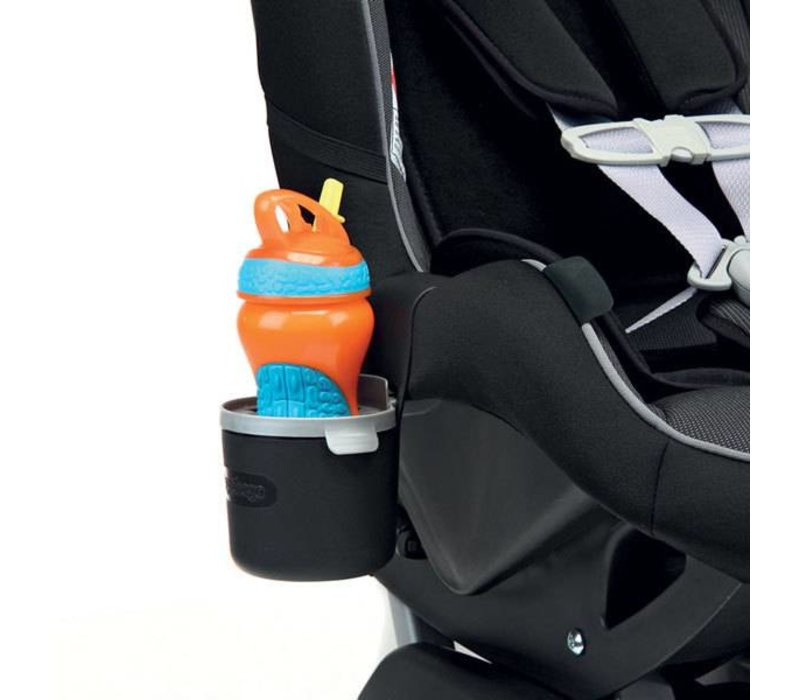Can the material of the car seat and the sippy cup be linked to environmentally friendly practices? While the image does not specify materials, manufacturers often use recyclable plastics and eco-friendly fabrics in modern car seats and sippy cups to appeal to environmentally conscious consumers. These materials are selected not only for durability and safety but also for their lower environmental impact, aligning with more sustainable manufacturing practices. 